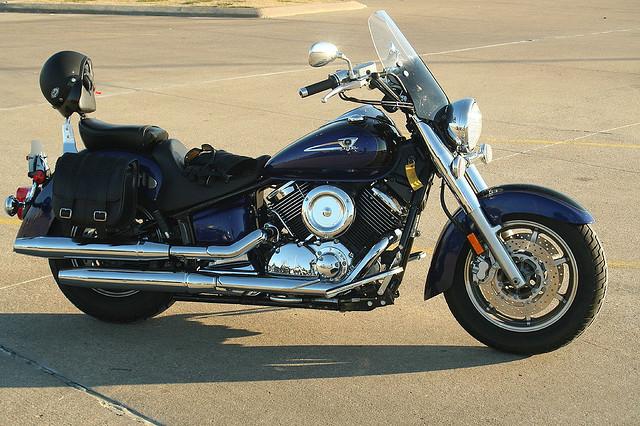How much do you think this motorbike costs?
Be succinct. 10,000 dollars. Is the bike on the grass?
Be succinct. No. Is there a helmet on the bike?
Concise answer only. Yes. 